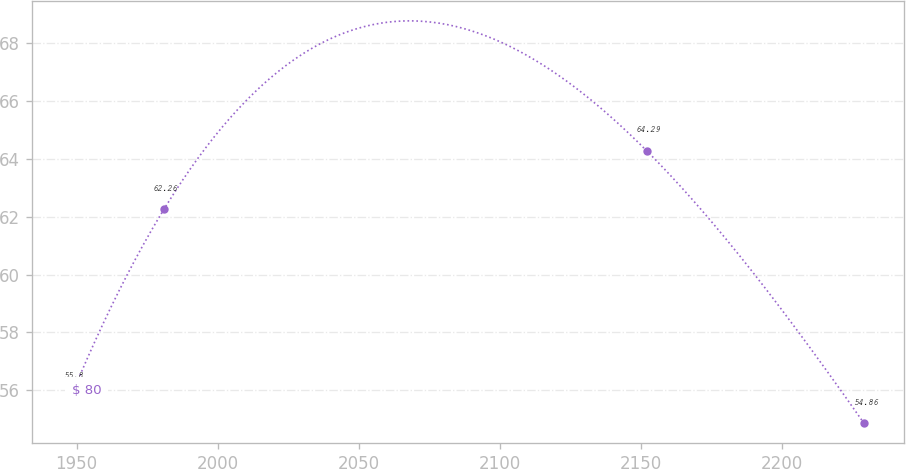Convert chart. <chart><loc_0><loc_0><loc_500><loc_500><line_chart><ecel><fcel>$ 80<nl><fcel>1948.11<fcel>55.8<nl><fcel>1980.98<fcel>62.26<nl><fcel>2152.09<fcel>64.29<nl><fcel>2229.17<fcel>54.86<nl></chart> 